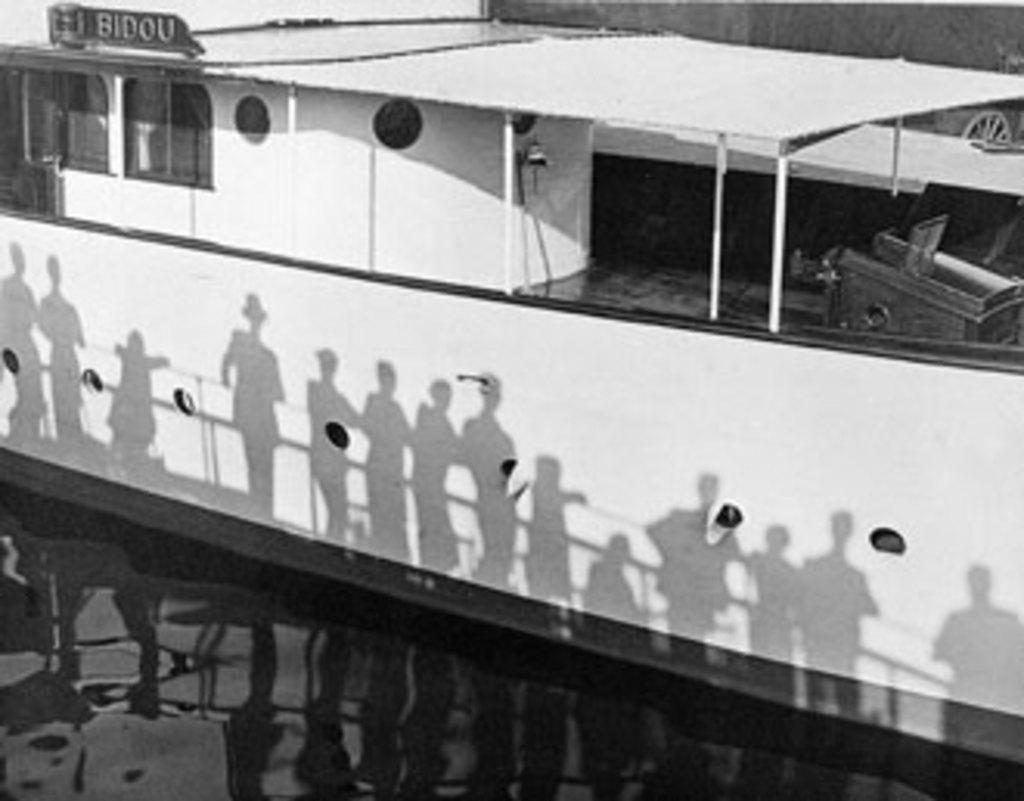<image>
Give a short and clear explanation of the subsequent image. A riverboat with the word Bidou written on the top of it 